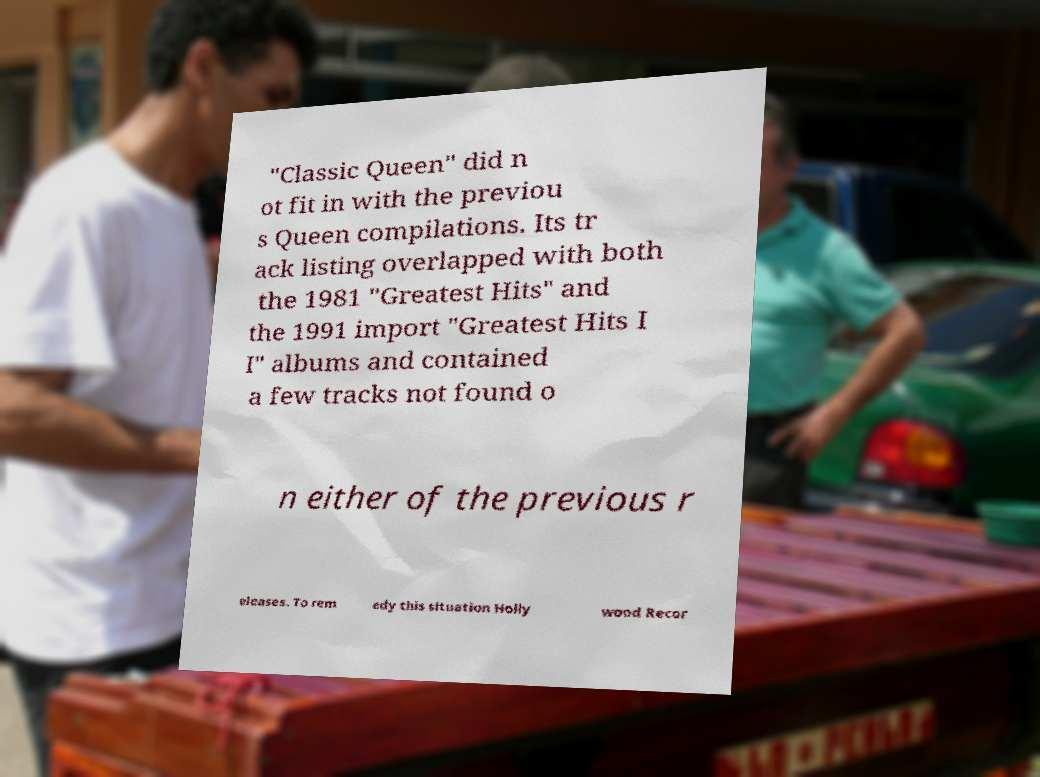What messages or text are displayed in this image? I need them in a readable, typed format. "Classic Queen" did n ot fit in with the previou s Queen compilations. Its tr ack listing overlapped with both the 1981 "Greatest Hits" and the 1991 import "Greatest Hits I I" albums and contained a few tracks not found o n either of the previous r eleases. To rem edy this situation Holly wood Recor 